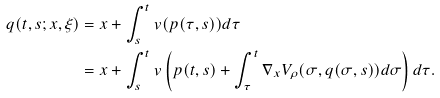<formula> <loc_0><loc_0><loc_500><loc_500>q ( t , s ; x , \xi ) & = x + \int _ { s } ^ { t } v ( p ( \tau , s ) ) d \tau \\ & = x + \int _ { s } ^ { t } v \left ( p ( t , s ) + \int _ { \tau } ^ { t } \nabla _ { x } V _ { \rho } ( \sigma , q ( \sigma , s ) ) d \sigma \right ) d \tau .</formula> 